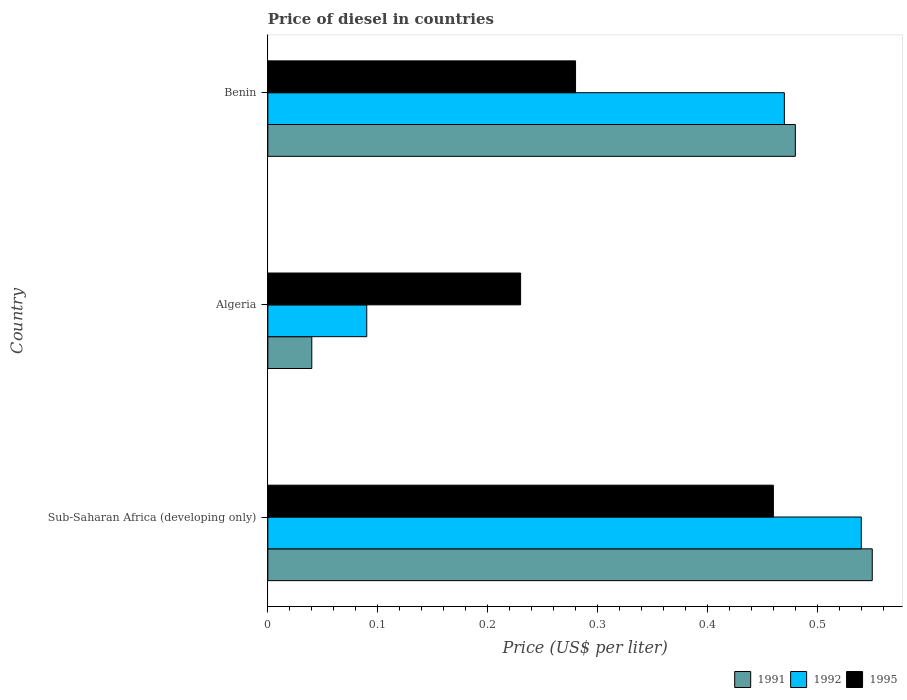Are the number of bars per tick equal to the number of legend labels?
Ensure brevity in your answer.  Yes. What is the label of the 2nd group of bars from the top?
Ensure brevity in your answer.  Algeria. In how many cases, is the number of bars for a given country not equal to the number of legend labels?
Offer a very short reply. 0. What is the price of diesel in 1991 in Benin?
Offer a terse response. 0.48. Across all countries, what is the maximum price of diesel in 1992?
Provide a short and direct response. 0.54. Across all countries, what is the minimum price of diesel in 1995?
Give a very brief answer. 0.23. In which country was the price of diesel in 1995 maximum?
Make the answer very short. Sub-Saharan Africa (developing only). In which country was the price of diesel in 1992 minimum?
Your answer should be compact. Algeria. What is the difference between the price of diesel in 1995 in Benin and that in Sub-Saharan Africa (developing only)?
Make the answer very short. -0.18. What is the difference between the price of diesel in 1992 in Algeria and the price of diesel in 1995 in Sub-Saharan Africa (developing only)?
Your answer should be very brief. -0.37. What is the average price of diesel in 1995 per country?
Make the answer very short. 0.32. What is the difference between the price of diesel in 1995 and price of diesel in 1991 in Algeria?
Offer a very short reply. 0.19. In how many countries, is the price of diesel in 1992 greater than 0.54 US$?
Give a very brief answer. 0. What is the ratio of the price of diesel in 1995 in Algeria to that in Benin?
Your answer should be very brief. 0.82. What is the difference between the highest and the second highest price of diesel in 1991?
Offer a very short reply. 0.07. What is the difference between the highest and the lowest price of diesel in 1991?
Ensure brevity in your answer.  0.51. In how many countries, is the price of diesel in 1991 greater than the average price of diesel in 1991 taken over all countries?
Make the answer very short. 2. How many bars are there?
Offer a very short reply. 9. Are all the bars in the graph horizontal?
Make the answer very short. Yes. What is the difference between two consecutive major ticks on the X-axis?
Keep it short and to the point. 0.1. Does the graph contain grids?
Provide a succinct answer. No. How many legend labels are there?
Your answer should be very brief. 3. How are the legend labels stacked?
Your response must be concise. Horizontal. What is the title of the graph?
Give a very brief answer. Price of diesel in countries. Does "1972" appear as one of the legend labels in the graph?
Keep it short and to the point. No. What is the label or title of the X-axis?
Offer a very short reply. Price (US$ per liter). What is the label or title of the Y-axis?
Ensure brevity in your answer.  Country. What is the Price (US$ per liter) in 1991 in Sub-Saharan Africa (developing only)?
Your response must be concise. 0.55. What is the Price (US$ per liter) in 1992 in Sub-Saharan Africa (developing only)?
Provide a short and direct response. 0.54. What is the Price (US$ per liter) in 1995 in Sub-Saharan Africa (developing only)?
Offer a terse response. 0.46. What is the Price (US$ per liter) of 1992 in Algeria?
Your response must be concise. 0.09. What is the Price (US$ per liter) in 1995 in Algeria?
Offer a terse response. 0.23. What is the Price (US$ per liter) of 1991 in Benin?
Make the answer very short. 0.48. What is the Price (US$ per liter) in 1992 in Benin?
Your answer should be compact. 0.47. What is the Price (US$ per liter) in 1995 in Benin?
Provide a succinct answer. 0.28. Across all countries, what is the maximum Price (US$ per liter) of 1991?
Your response must be concise. 0.55. Across all countries, what is the maximum Price (US$ per liter) of 1992?
Give a very brief answer. 0.54. Across all countries, what is the maximum Price (US$ per liter) in 1995?
Offer a very short reply. 0.46. Across all countries, what is the minimum Price (US$ per liter) in 1992?
Provide a succinct answer. 0.09. Across all countries, what is the minimum Price (US$ per liter) in 1995?
Your answer should be compact. 0.23. What is the total Price (US$ per liter) of 1991 in the graph?
Your answer should be very brief. 1.07. What is the difference between the Price (US$ per liter) of 1991 in Sub-Saharan Africa (developing only) and that in Algeria?
Provide a short and direct response. 0.51. What is the difference between the Price (US$ per liter) in 1992 in Sub-Saharan Africa (developing only) and that in Algeria?
Your answer should be very brief. 0.45. What is the difference between the Price (US$ per liter) in 1995 in Sub-Saharan Africa (developing only) and that in Algeria?
Your response must be concise. 0.23. What is the difference between the Price (US$ per liter) of 1991 in Sub-Saharan Africa (developing only) and that in Benin?
Offer a very short reply. 0.07. What is the difference between the Price (US$ per liter) of 1992 in Sub-Saharan Africa (developing only) and that in Benin?
Offer a terse response. 0.07. What is the difference between the Price (US$ per liter) of 1995 in Sub-Saharan Africa (developing only) and that in Benin?
Provide a short and direct response. 0.18. What is the difference between the Price (US$ per liter) of 1991 in Algeria and that in Benin?
Your response must be concise. -0.44. What is the difference between the Price (US$ per liter) of 1992 in Algeria and that in Benin?
Your answer should be very brief. -0.38. What is the difference between the Price (US$ per liter) of 1991 in Sub-Saharan Africa (developing only) and the Price (US$ per liter) of 1992 in Algeria?
Ensure brevity in your answer.  0.46. What is the difference between the Price (US$ per liter) of 1991 in Sub-Saharan Africa (developing only) and the Price (US$ per liter) of 1995 in Algeria?
Keep it short and to the point. 0.32. What is the difference between the Price (US$ per liter) in 1992 in Sub-Saharan Africa (developing only) and the Price (US$ per liter) in 1995 in Algeria?
Give a very brief answer. 0.31. What is the difference between the Price (US$ per liter) in 1991 in Sub-Saharan Africa (developing only) and the Price (US$ per liter) in 1992 in Benin?
Your response must be concise. 0.08. What is the difference between the Price (US$ per liter) of 1991 in Sub-Saharan Africa (developing only) and the Price (US$ per liter) of 1995 in Benin?
Your answer should be very brief. 0.27. What is the difference between the Price (US$ per liter) of 1992 in Sub-Saharan Africa (developing only) and the Price (US$ per liter) of 1995 in Benin?
Offer a very short reply. 0.26. What is the difference between the Price (US$ per liter) of 1991 in Algeria and the Price (US$ per liter) of 1992 in Benin?
Provide a succinct answer. -0.43. What is the difference between the Price (US$ per liter) in 1991 in Algeria and the Price (US$ per liter) in 1995 in Benin?
Make the answer very short. -0.24. What is the difference between the Price (US$ per liter) of 1992 in Algeria and the Price (US$ per liter) of 1995 in Benin?
Make the answer very short. -0.19. What is the average Price (US$ per liter) in 1991 per country?
Your answer should be very brief. 0.36. What is the average Price (US$ per liter) of 1992 per country?
Ensure brevity in your answer.  0.37. What is the average Price (US$ per liter) of 1995 per country?
Keep it short and to the point. 0.32. What is the difference between the Price (US$ per liter) of 1991 and Price (US$ per liter) of 1992 in Sub-Saharan Africa (developing only)?
Offer a very short reply. 0.01. What is the difference between the Price (US$ per liter) in 1991 and Price (US$ per liter) in 1995 in Sub-Saharan Africa (developing only)?
Give a very brief answer. 0.09. What is the difference between the Price (US$ per liter) of 1991 and Price (US$ per liter) of 1992 in Algeria?
Provide a succinct answer. -0.05. What is the difference between the Price (US$ per liter) in 1991 and Price (US$ per liter) in 1995 in Algeria?
Your answer should be compact. -0.19. What is the difference between the Price (US$ per liter) in 1992 and Price (US$ per liter) in 1995 in Algeria?
Offer a very short reply. -0.14. What is the difference between the Price (US$ per liter) of 1991 and Price (US$ per liter) of 1995 in Benin?
Provide a succinct answer. 0.2. What is the difference between the Price (US$ per liter) of 1992 and Price (US$ per liter) of 1995 in Benin?
Offer a very short reply. 0.19. What is the ratio of the Price (US$ per liter) in 1991 in Sub-Saharan Africa (developing only) to that in Algeria?
Your response must be concise. 13.75. What is the ratio of the Price (US$ per liter) in 1992 in Sub-Saharan Africa (developing only) to that in Algeria?
Give a very brief answer. 6. What is the ratio of the Price (US$ per liter) of 1991 in Sub-Saharan Africa (developing only) to that in Benin?
Provide a succinct answer. 1.15. What is the ratio of the Price (US$ per liter) in 1992 in Sub-Saharan Africa (developing only) to that in Benin?
Give a very brief answer. 1.15. What is the ratio of the Price (US$ per liter) in 1995 in Sub-Saharan Africa (developing only) to that in Benin?
Make the answer very short. 1.64. What is the ratio of the Price (US$ per liter) in 1991 in Algeria to that in Benin?
Your response must be concise. 0.08. What is the ratio of the Price (US$ per liter) of 1992 in Algeria to that in Benin?
Provide a succinct answer. 0.19. What is the ratio of the Price (US$ per liter) in 1995 in Algeria to that in Benin?
Make the answer very short. 0.82. What is the difference between the highest and the second highest Price (US$ per liter) in 1991?
Give a very brief answer. 0.07. What is the difference between the highest and the second highest Price (US$ per liter) of 1992?
Make the answer very short. 0.07. What is the difference between the highest and the second highest Price (US$ per liter) of 1995?
Give a very brief answer. 0.18. What is the difference between the highest and the lowest Price (US$ per liter) in 1991?
Make the answer very short. 0.51. What is the difference between the highest and the lowest Price (US$ per liter) in 1992?
Your answer should be compact. 0.45. What is the difference between the highest and the lowest Price (US$ per liter) of 1995?
Provide a short and direct response. 0.23. 